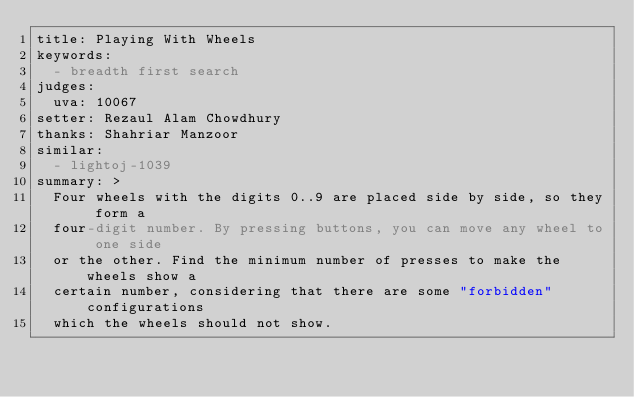<code> <loc_0><loc_0><loc_500><loc_500><_YAML_>title: Playing With Wheels
keywords:
  - breadth first search
judges:
  uva: 10067
setter: Rezaul Alam Chowdhury
thanks: Shahriar Manzoor
similar:
  - lightoj-1039
summary: >
  Four wheels with the digits 0..9 are placed side by side, so they form a
  four-digit number. By pressing buttons, you can move any wheel to one side
  or the other. Find the minimum number of presses to make the wheels show a
  certain number, considering that there are some "forbidden" configurations
  which the wheels should not show.
</code> 